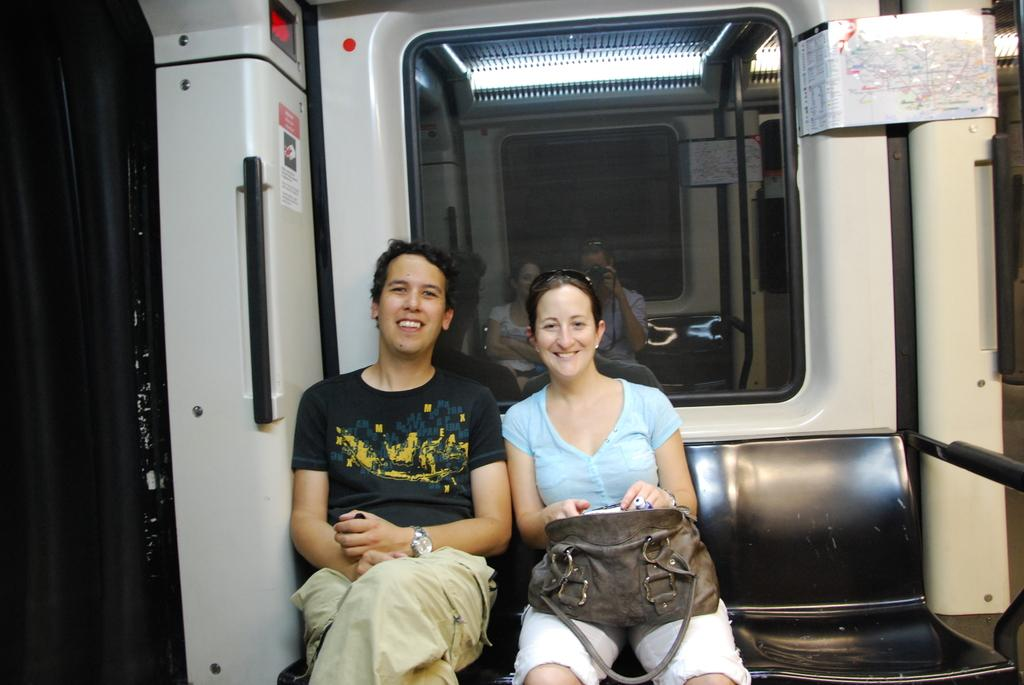How many people are in the image? There are two people in the image, a man and a woman. What are the man and the woman doing in the image? Both the man and the woman are sitting on a bench. What is the woman holding in the image? The woman is holding a bag. What can be observed about the facial expressions of the man and the woman? There is a smile on the faces of both the man and the woman. What type of soda is the man drinking in the image? There is no soda present in the image; the man and the woman are sitting on a bench and smiling. Can you tell me how many goldfish are swimming in the bag held by the woman? There is no bag containing goldfish in the image; the woman is holding a regular bag. 